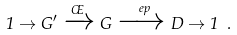<formula> <loc_0><loc_0><loc_500><loc_500>1 \to G ^ { \prime } \xrightarrow { \phi } G \xrightarrow { \ e p } D \to 1 \ .</formula> 